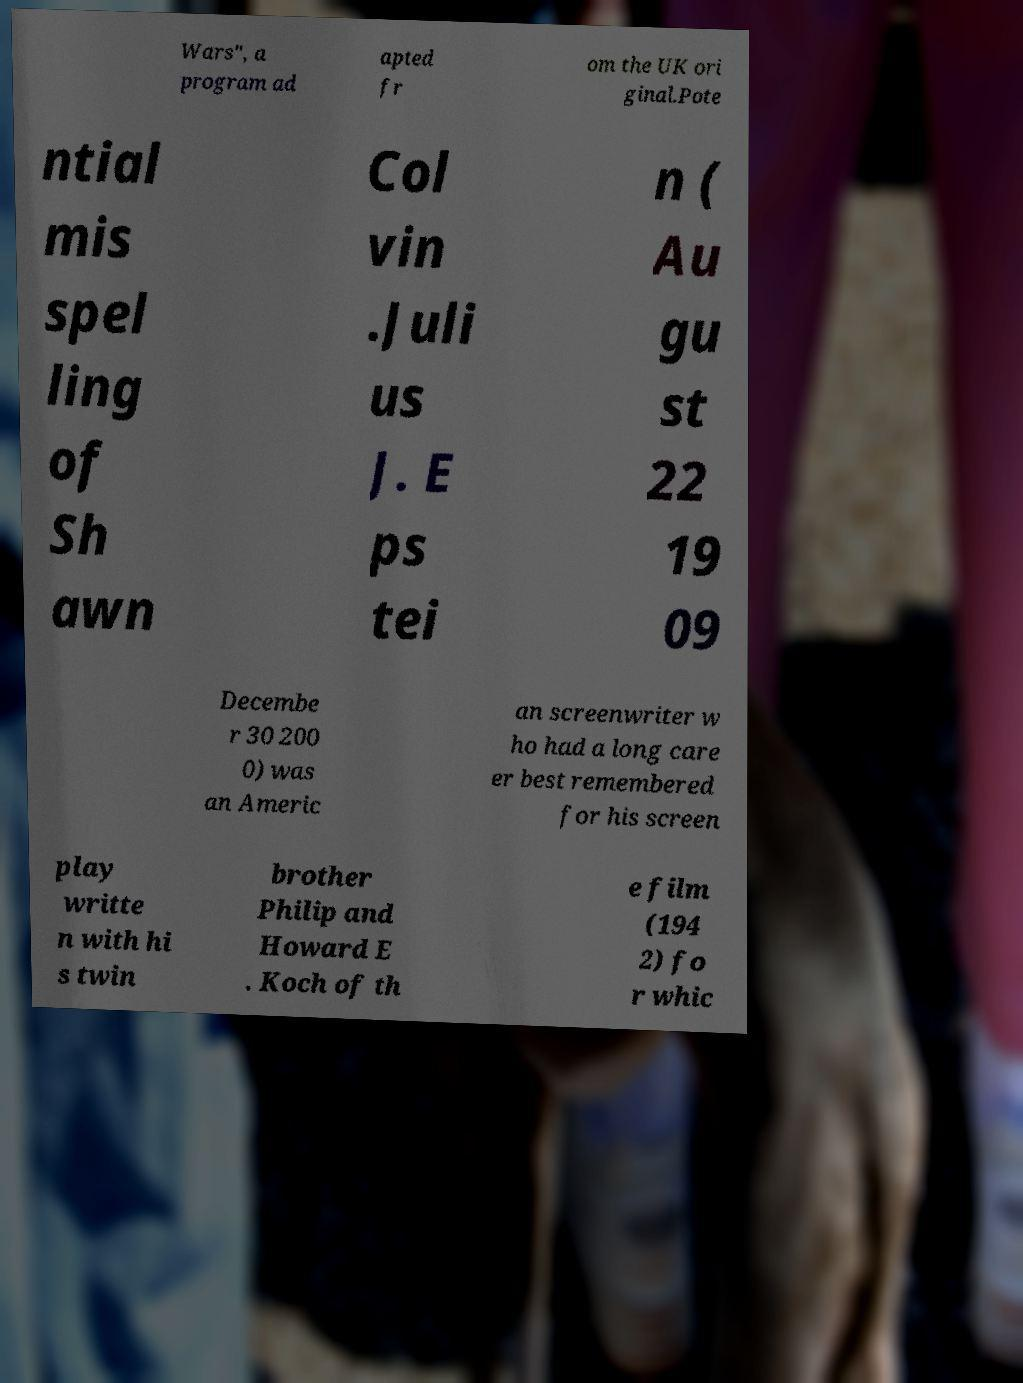Can you accurately transcribe the text from the provided image for me? Wars", a program ad apted fr om the UK ori ginal.Pote ntial mis spel ling of Sh awn Col vin .Juli us J. E ps tei n ( Au gu st 22 19 09 Decembe r 30 200 0) was an Americ an screenwriter w ho had a long care er best remembered for his screen play writte n with hi s twin brother Philip and Howard E . Koch of th e film (194 2) fo r whic 